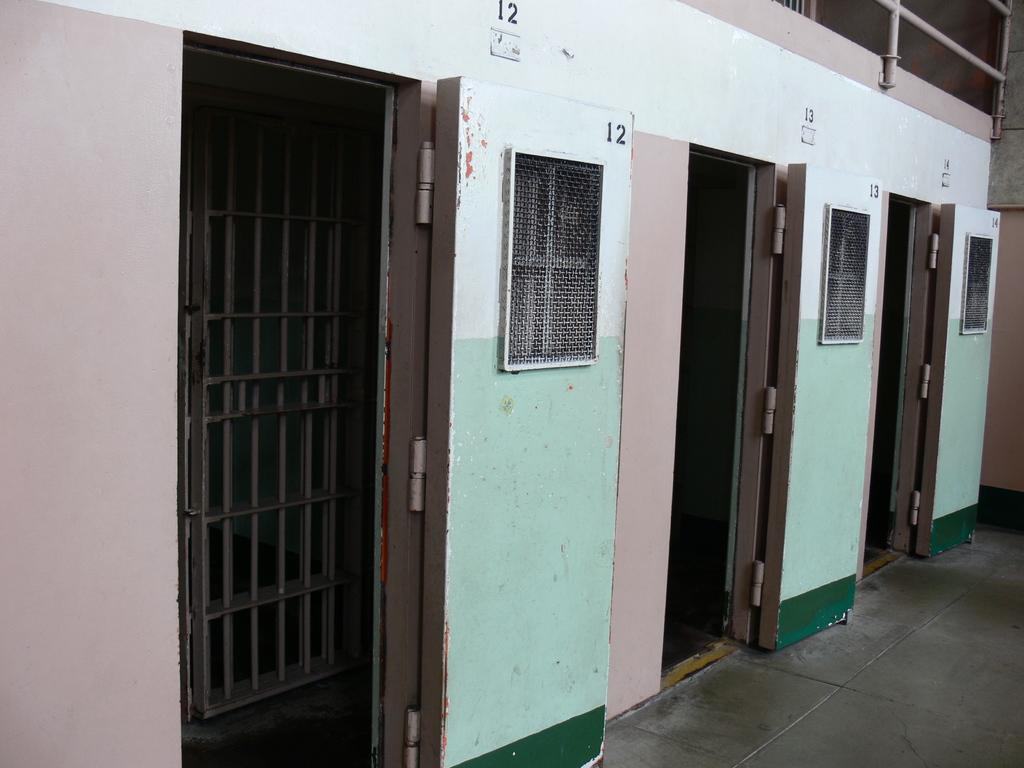What type of structure can be seen in the image? There is a wall in the image. Are there any openings in the wall? Yes, there are doors and windows in the image. What is written on the wall? Numbers are written on the wall. What feature is present at the top of the wall? There is a railing at the top of the wall. How many bears are holding a yoke in the image? There are no bears or yokes present in the image. What emotion is expressed by the wall in the image? Walls do not express emotions; they are inanimate objects. 